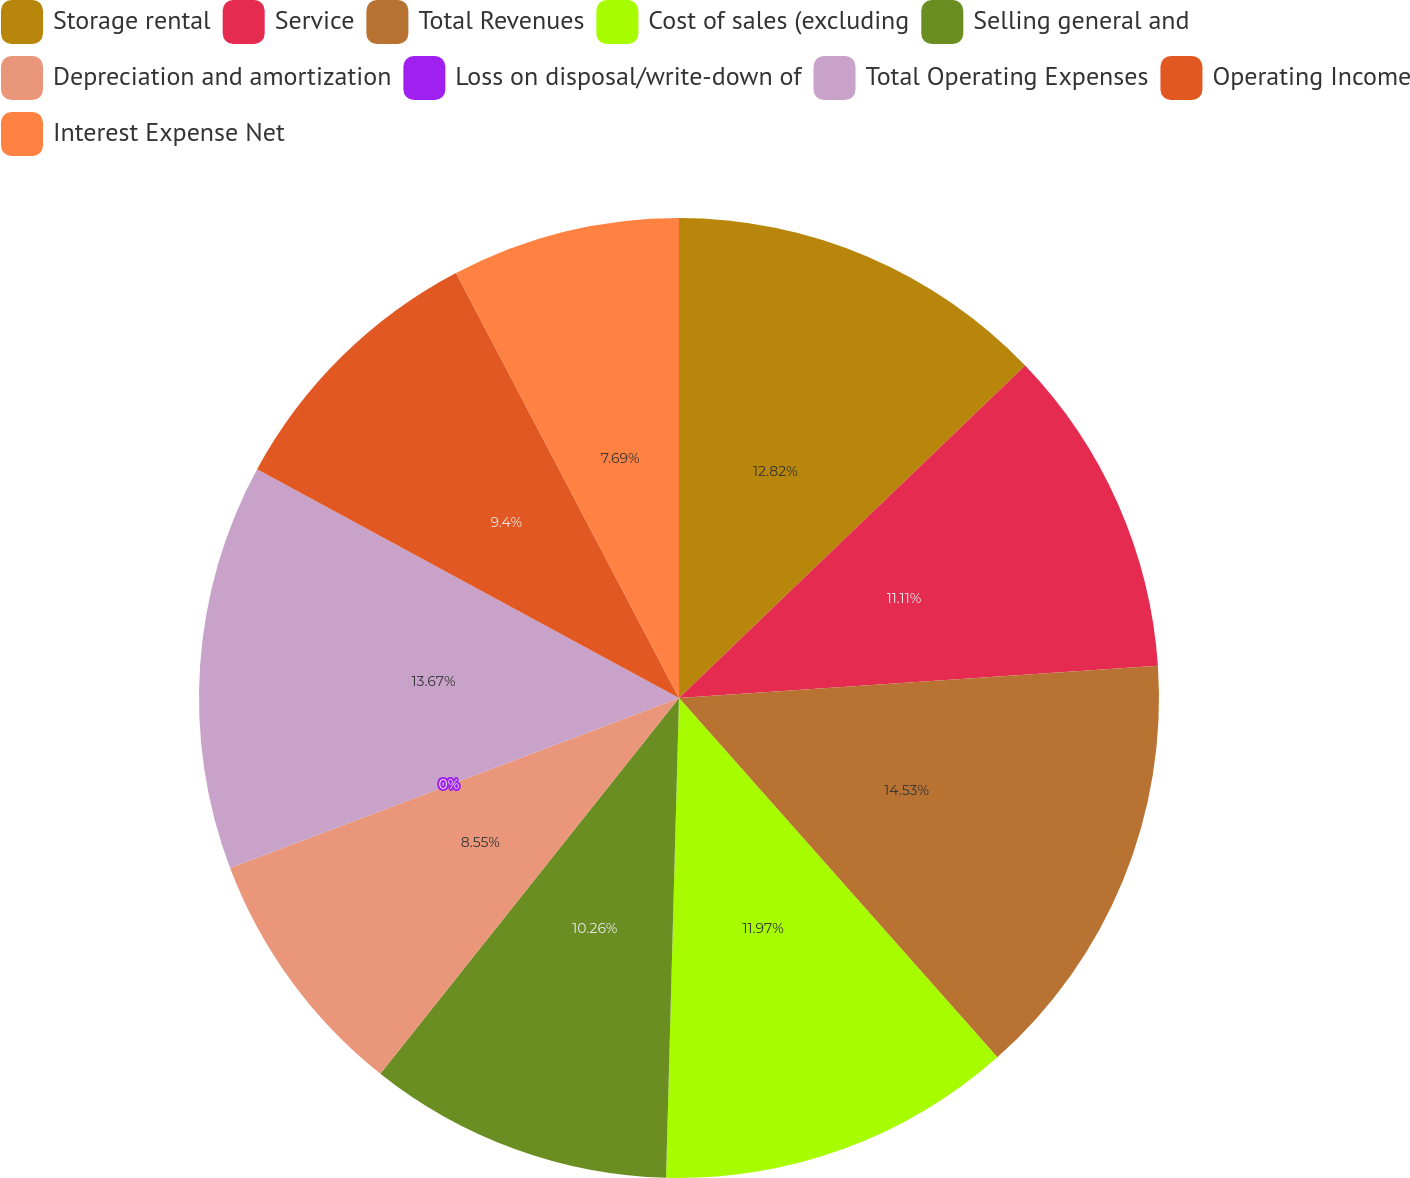<chart> <loc_0><loc_0><loc_500><loc_500><pie_chart><fcel>Storage rental<fcel>Service<fcel>Total Revenues<fcel>Cost of sales (excluding<fcel>Selling general and<fcel>Depreciation and amortization<fcel>Loss on disposal/write-down of<fcel>Total Operating Expenses<fcel>Operating Income<fcel>Interest Expense Net<nl><fcel>12.82%<fcel>11.11%<fcel>14.53%<fcel>11.97%<fcel>10.26%<fcel>8.55%<fcel>0.0%<fcel>13.67%<fcel>9.4%<fcel>7.69%<nl></chart> 